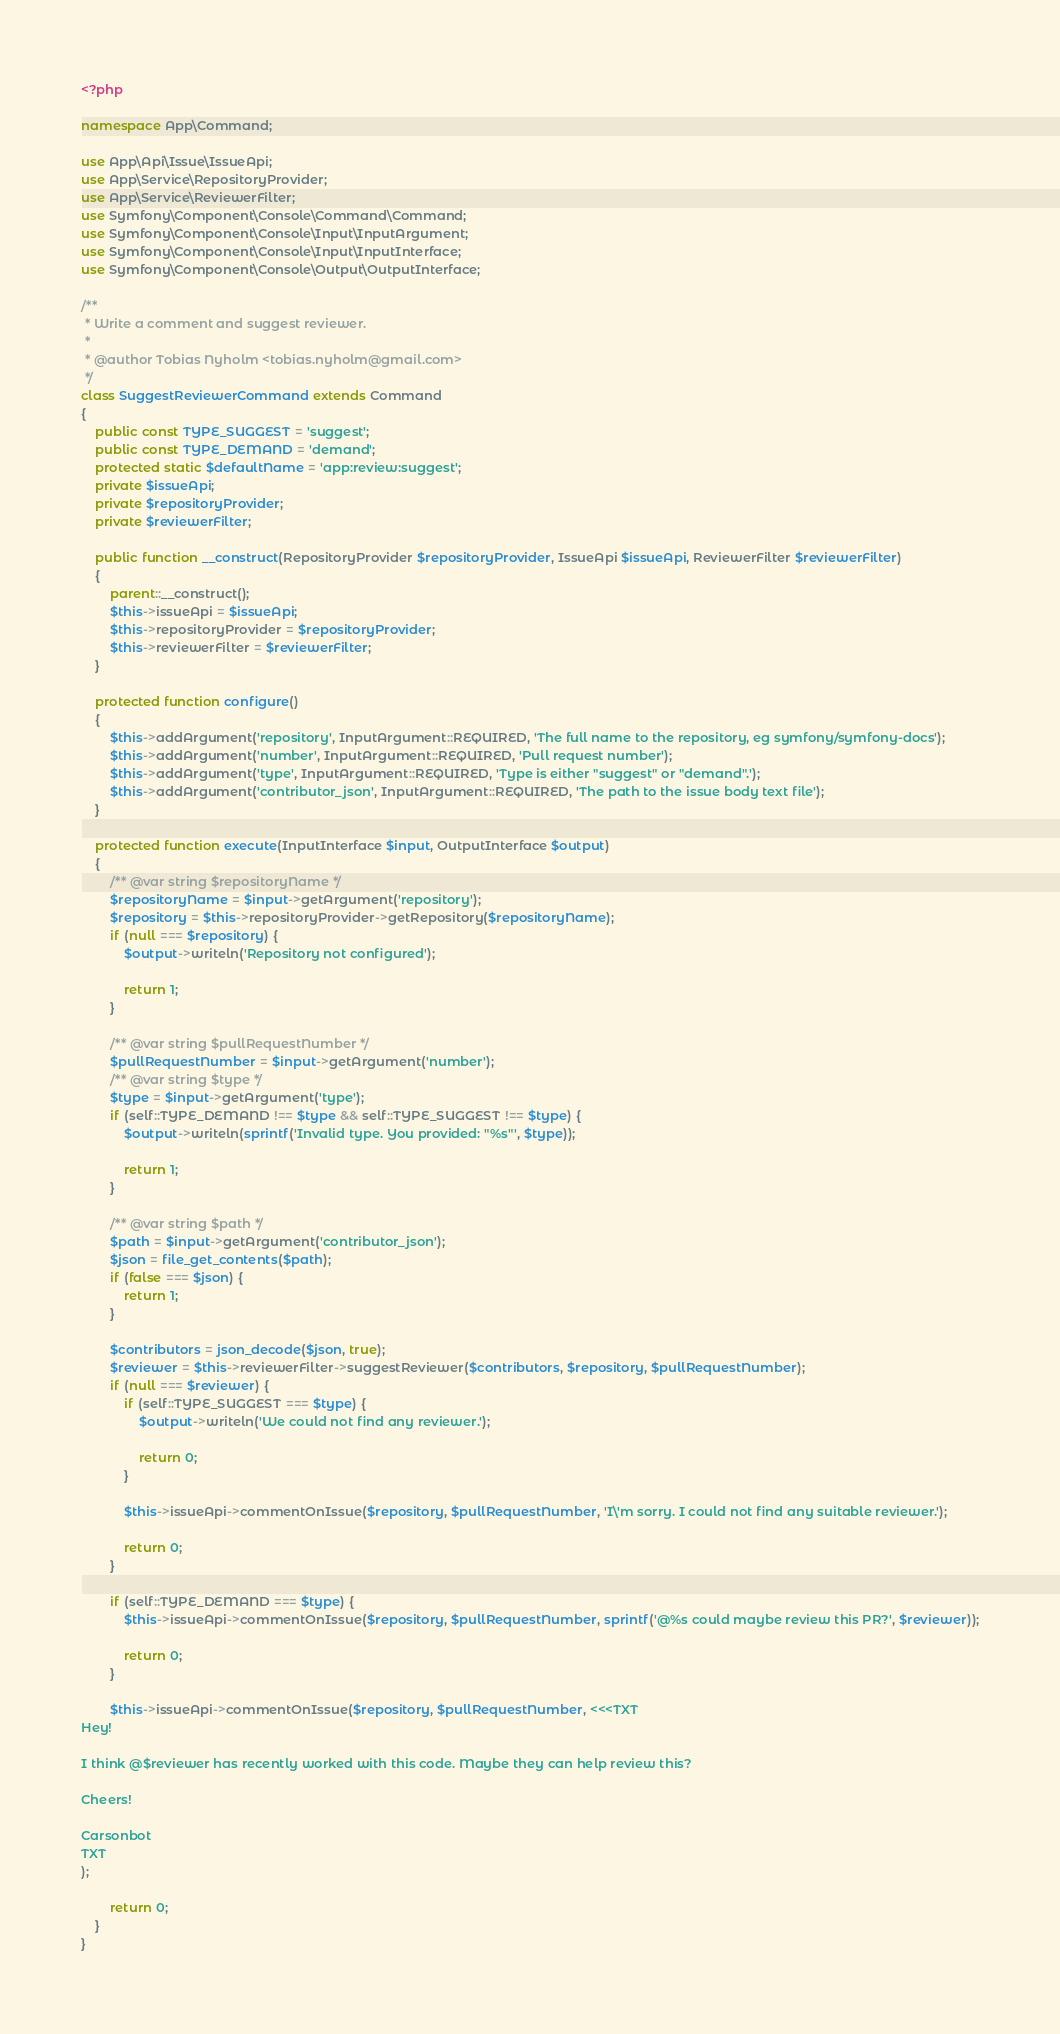Convert code to text. <code><loc_0><loc_0><loc_500><loc_500><_PHP_><?php

namespace App\Command;

use App\Api\Issue\IssueApi;
use App\Service\RepositoryProvider;
use App\Service\ReviewerFilter;
use Symfony\Component\Console\Command\Command;
use Symfony\Component\Console\Input\InputArgument;
use Symfony\Component\Console\Input\InputInterface;
use Symfony\Component\Console\Output\OutputInterface;

/**
 * Write a comment and suggest reviewer.
 *
 * @author Tobias Nyholm <tobias.nyholm@gmail.com>
 */
class SuggestReviewerCommand extends Command
{
    public const TYPE_SUGGEST = 'suggest';
    public const TYPE_DEMAND = 'demand';
    protected static $defaultName = 'app:review:suggest';
    private $issueApi;
    private $repositoryProvider;
    private $reviewerFilter;

    public function __construct(RepositoryProvider $repositoryProvider, IssueApi $issueApi, ReviewerFilter $reviewerFilter)
    {
        parent::__construct();
        $this->issueApi = $issueApi;
        $this->repositoryProvider = $repositoryProvider;
        $this->reviewerFilter = $reviewerFilter;
    }

    protected function configure()
    {
        $this->addArgument('repository', InputArgument::REQUIRED, 'The full name to the repository, eg symfony/symfony-docs');
        $this->addArgument('number', InputArgument::REQUIRED, 'Pull request number');
        $this->addArgument('type', InputArgument::REQUIRED, 'Type is either "suggest" or "demand".');
        $this->addArgument('contributor_json', InputArgument::REQUIRED, 'The path to the issue body text file');
    }

    protected function execute(InputInterface $input, OutputInterface $output)
    {
        /** @var string $repositoryName */
        $repositoryName = $input->getArgument('repository');
        $repository = $this->repositoryProvider->getRepository($repositoryName);
        if (null === $repository) {
            $output->writeln('Repository not configured');

            return 1;
        }

        /** @var string $pullRequestNumber */
        $pullRequestNumber = $input->getArgument('number');
        /** @var string $type */
        $type = $input->getArgument('type');
        if (self::TYPE_DEMAND !== $type && self::TYPE_SUGGEST !== $type) {
            $output->writeln(sprintf('Invalid type. You provided: "%s"', $type));

            return 1;
        }

        /** @var string $path */
        $path = $input->getArgument('contributor_json');
        $json = file_get_contents($path);
        if (false === $json) {
            return 1;
        }

        $contributors = json_decode($json, true);
        $reviewer = $this->reviewerFilter->suggestReviewer($contributors, $repository, $pullRequestNumber);
        if (null === $reviewer) {
            if (self::TYPE_SUGGEST === $type) {
                $output->writeln('We could not find any reviewer.');

                return 0;
            }

            $this->issueApi->commentOnIssue($repository, $pullRequestNumber, 'I\'m sorry. I could not find any suitable reviewer.');

            return 0;
        }

        if (self::TYPE_DEMAND === $type) {
            $this->issueApi->commentOnIssue($repository, $pullRequestNumber, sprintf('@%s could maybe review this PR?', $reviewer));

            return 0;
        }

        $this->issueApi->commentOnIssue($repository, $pullRequestNumber, <<<TXT
Hey!

I think @$reviewer has recently worked with this code. Maybe they can help review this?

Cheers!

Carsonbot
TXT
);

        return 0;
    }
}
</code> 